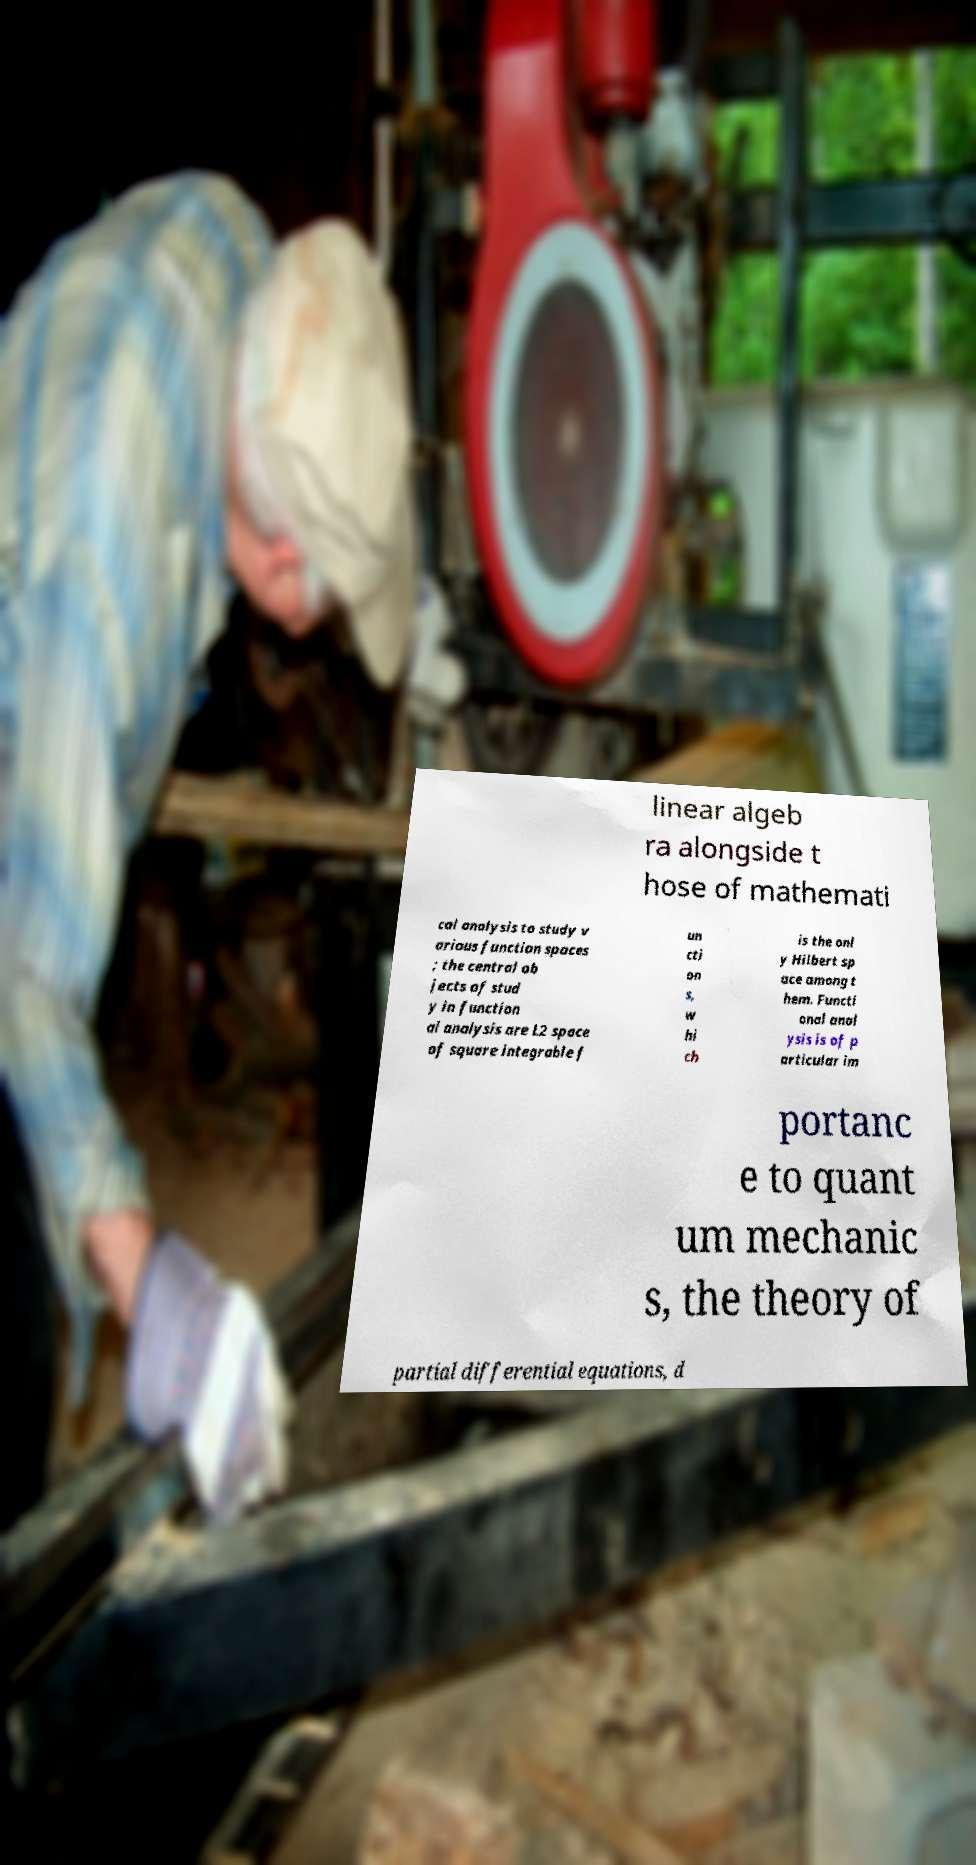What messages or text are displayed in this image? I need them in a readable, typed format. linear algeb ra alongside t hose of mathemati cal analysis to study v arious function spaces ; the central ob jects of stud y in function al analysis are L2 space of square integrable f un cti on s, w hi ch is the onl y Hilbert sp ace among t hem. Functi onal anal ysis is of p articular im portanc e to quant um mechanic s, the theory of partial differential equations, d 